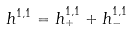Convert formula to latex. <formula><loc_0><loc_0><loc_500><loc_500>h ^ { 1 , 1 } = h _ { + } ^ { 1 , 1 } + h _ { - } ^ { 1 , 1 }</formula> 